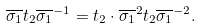Convert formula to latex. <formula><loc_0><loc_0><loc_500><loc_500>\overline { \sigma _ { 1 } } t _ { 2 } \overline { \sigma _ { 1 } } ^ { - 1 } = t _ { 2 } \cdot \overline { \sigma _ { 1 } } ^ { 2 } t _ { 2 } \overline { \sigma _ { 1 } } ^ { - 2 } .</formula> 